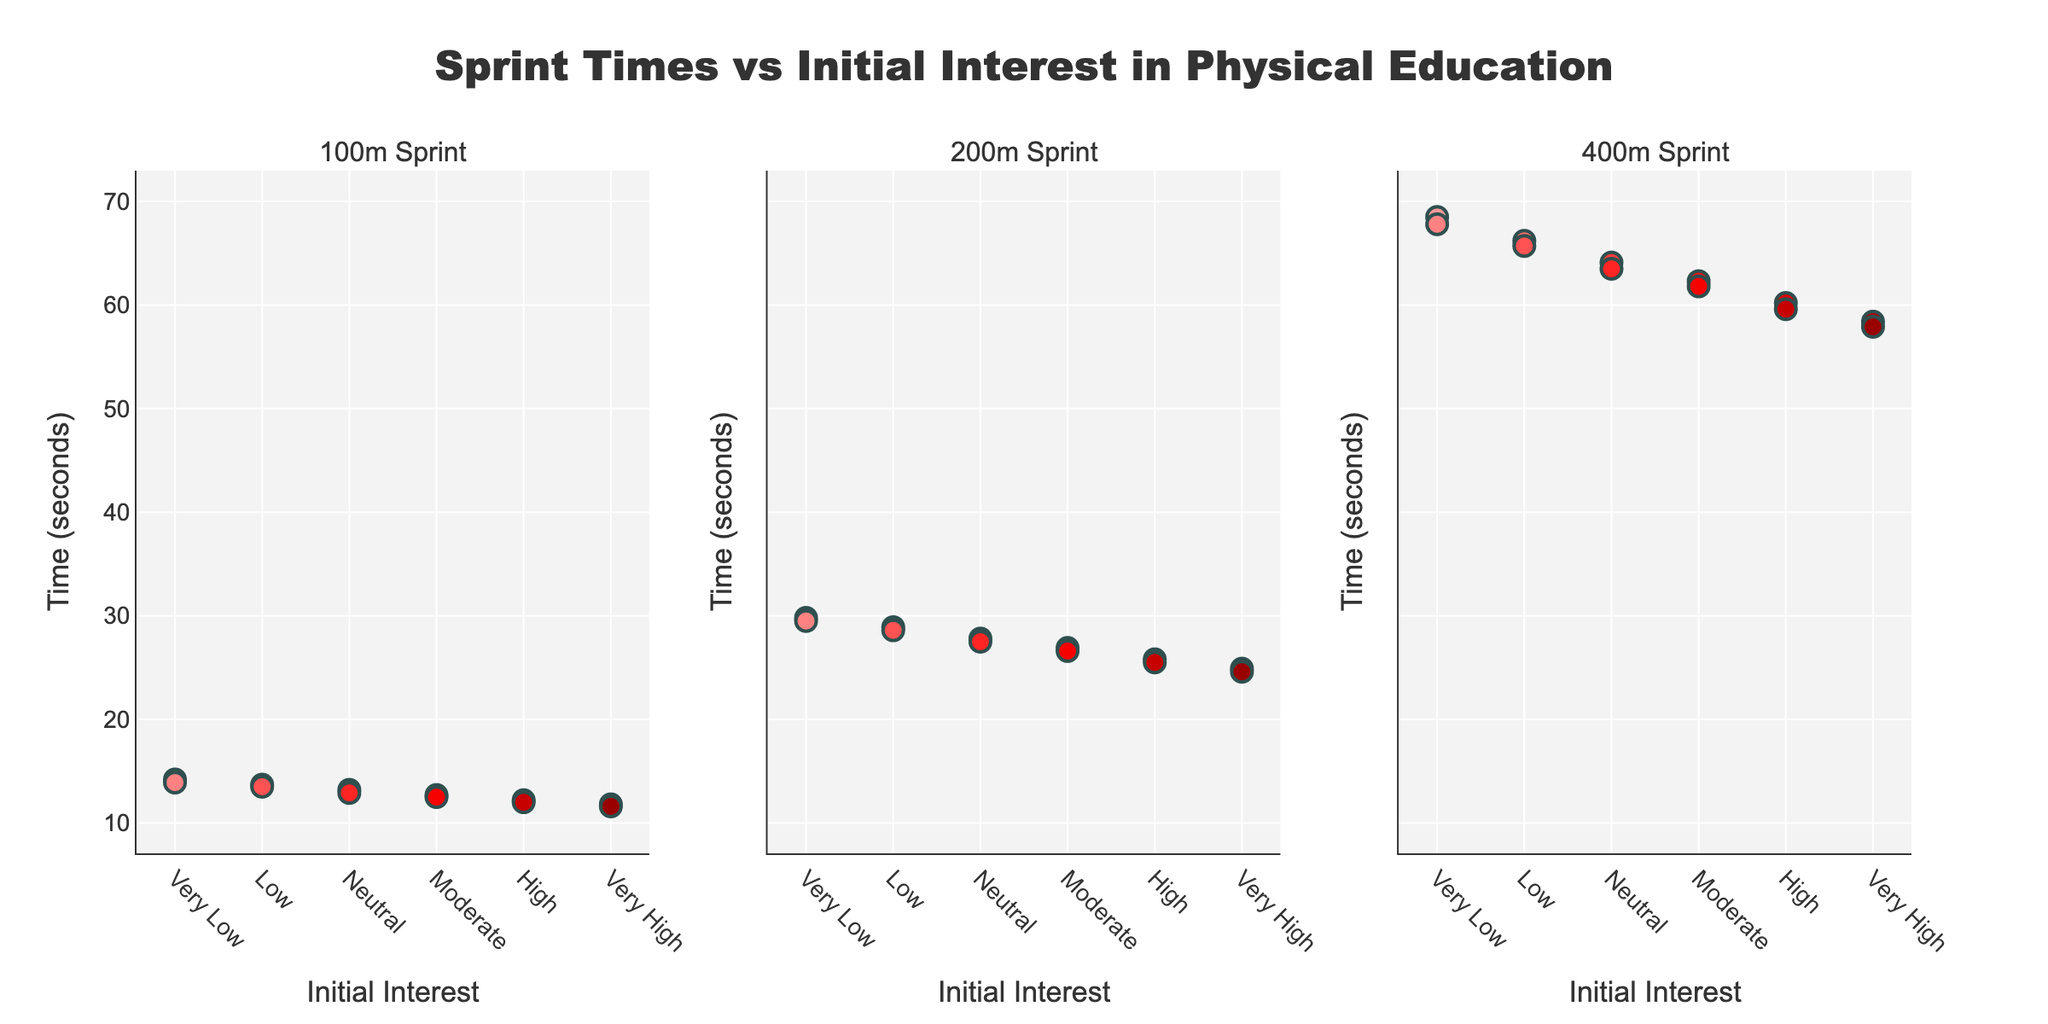What is the title of the figure? The title is presented at the top center of the figure. It reads "Sprint Times vs Initial Interest in Physical Education".
Answer: Sprint Times vs Initial Interest in Physical Education How many scatter plots are there in the figure? The subplot figure consists of three individual scatter plots as indicated by the sub-headings "100m Sprint", "200m Sprint", and "400m Sprint" at the top of each plot.
Answer: Three What does the y-axis represent in each subplot? The y-axis represents the "Time (seconds)" across all three subplots. This is consistent and marked on the y-axis labels.
Answer: Time (seconds) How does the 100m sprint time change with increasing initial interest in physical education? As initial interest in physical education increases from "Very Low" to "Very High", the 100m sprint time decreases consistently on the scatter plot.
Answer: Decreases Which initial interest group has the fastest average 400m sprint time? The "Very High" initial interest group has the fastest average 400m sprint time. This is seen at the lowest y-value for the "Very High" group in the 400m subplot.
Answer: Very High Compare the average sprint times for the "Low" interest group between the 100m and 400m sprints. The average 100m sprint time for the "Low" interest group is 13.6 seconds (average of 13.7 and 13.5). The average 400m sprint time is 66.0 seconds (average of 66.2 and 65.7). To compare, the 400m sprint takes significantly longer than the 100m sprint.
Answer: The 400m sprint takes significantly longer Which sprint distance shows the largest variation in times for the “Neutral” initial interest group? The variation in times can be observed by the range between the highest and lowest values in each plot for the "Neutral" interest group. The 200m sprint has a range of 27.8 to 27.5 seconds, while the 100m and 400m have 13.2 to 12.9 and 64.1 to 63.5 seconds, respectively. The largest variation is seen in the 400m sprint.
Answer: 400m Sprint What is the trend observed in sprint times as interest levels increase across all three sprints? For all three sprints (100m, 200m, and 400m), there is a downward trend in times as initial interest levels increase from "Very Low" to "Very High", indicating that higher initial interest correlates to better (faster) sprint times.
Answer: Decreasing trend What is the difference in the average 100m sprint time between the "Very Low" and "Very High" interest groups? The average 100m sprint time for the "Very Low" group is 14.05 seconds (average of 14.2 and 13.9), and for the "Very High" group is 11.7 seconds (average of 11.8 and 11.6). The difference is 14.05 - 11.7 = 2.35 seconds.
Answer: 2.35 seconds 